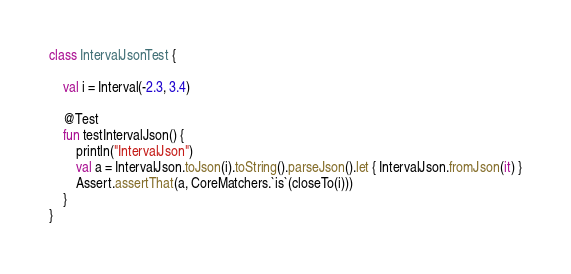Convert code to text. <code><loc_0><loc_0><loc_500><loc_500><_Kotlin_>class IntervalJsonTest {

    val i = Interval(-2.3, 3.4)

    @Test
    fun testIntervalJson() {
        println("IntervalJson")
        val a = IntervalJson.toJson(i).toString().parseJson().let { IntervalJson.fromJson(it) }
        Assert.assertThat(a, CoreMatchers.`is`(closeTo(i)))
    }
}</code> 